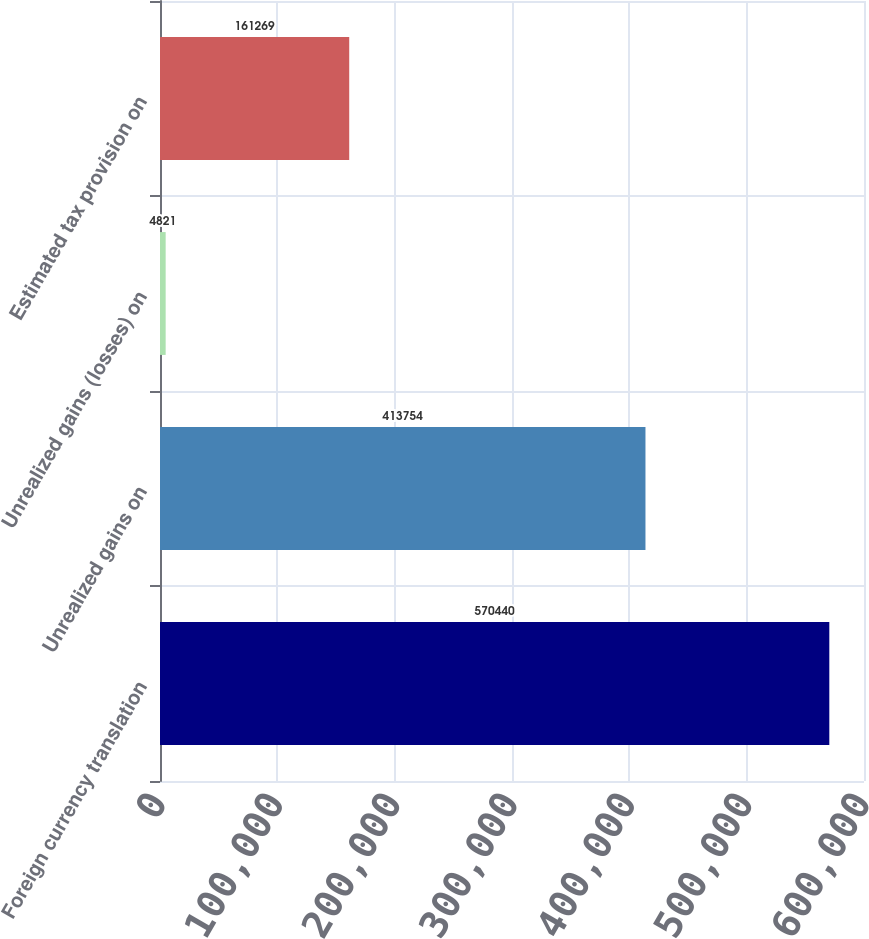Convert chart to OTSL. <chart><loc_0><loc_0><loc_500><loc_500><bar_chart><fcel>Foreign currency translation<fcel>Unrealized gains on<fcel>Unrealized gains (losses) on<fcel>Estimated tax provision on<nl><fcel>570440<fcel>413754<fcel>4821<fcel>161269<nl></chart> 